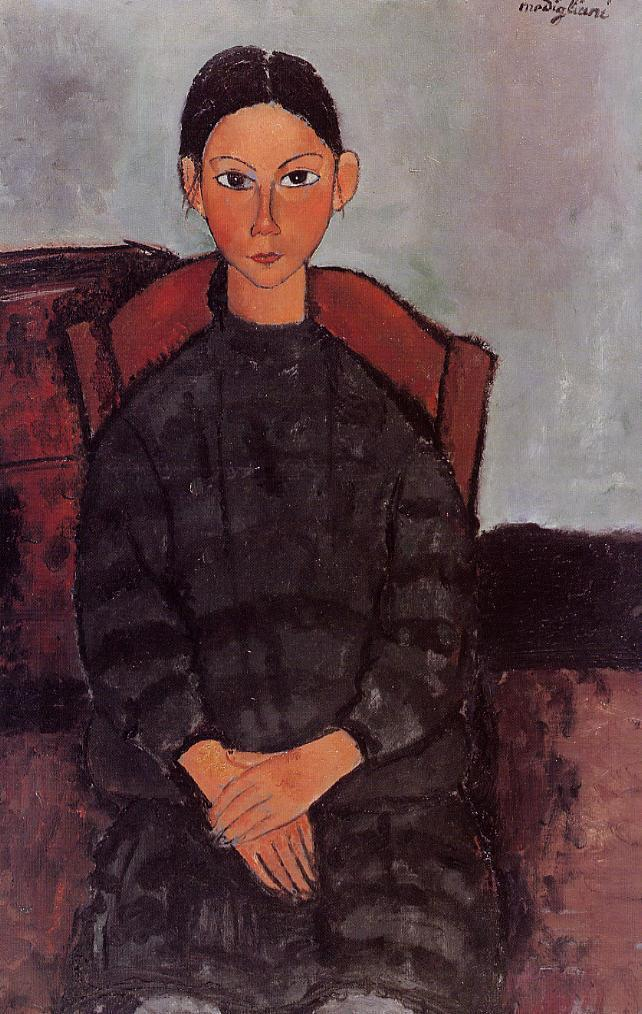Could there be a story behind this painting? Certainly, this painting could depict a narrative of a woman from an earlier era, perhaps a portrayal of her role in society, personal identity, or a particular moment in her life. The austere elegance of her attire and the painting's ambiance might imply a background of sophistication or introspection. The artist has left subtle clues in her posture and expression that invite viewers to imagine her thoughts or life story. 